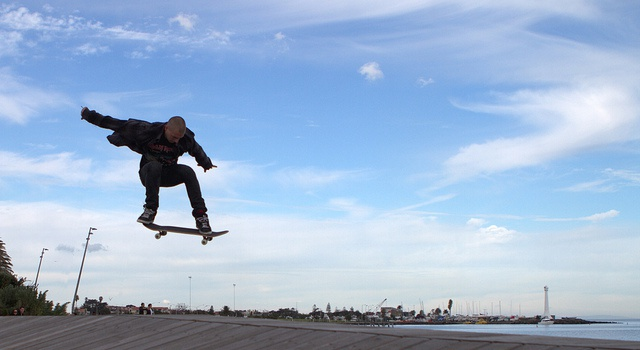Describe the objects in this image and their specific colors. I can see people in darkgray, black, lightblue, and maroon tones, skateboard in darkgray, lightgray, black, gray, and maroon tones, boat in darkgray, gray, and black tones, people in darkgray, black, gray, and maroon tones, and people in darkgray, black, maroon, and gray tones in this image. 